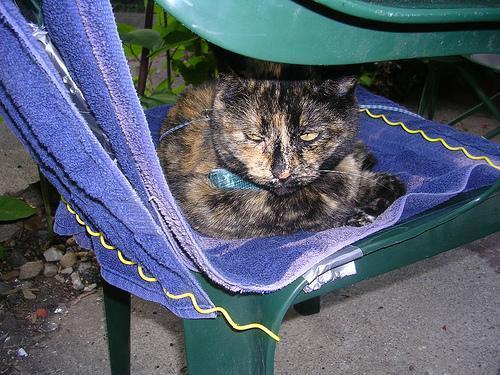How many chairs can you see?
Give a very brief answer. 1. 